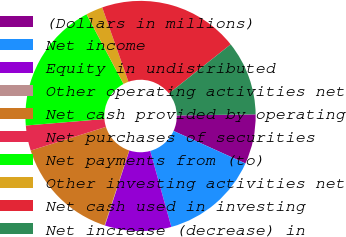Convert chart. <chart><loc_0><loc_0><loc_500><loc_500><pie_chart><fcel>(Dollars in millions)<fcel>Net income<fcel>Equity in undistributed<fcel>Other operating activities net<fcel>Net cash provided by operating<fcel>Net purchases of securities<fcel>Net payments from (to)<fcel>Other investing activities net<fcel>Net cash used in investing<fcel>Net increase (decrease) in<nl><fcel>6.99%<fcel>13.93%<fcel>9.31%<fcel>0.06%<fcel>15.09%<fcel>3.53%<fcel>18.55%<fcel>2.37%<fcel>19.71%<fcel>10.46%<nl></chart> 